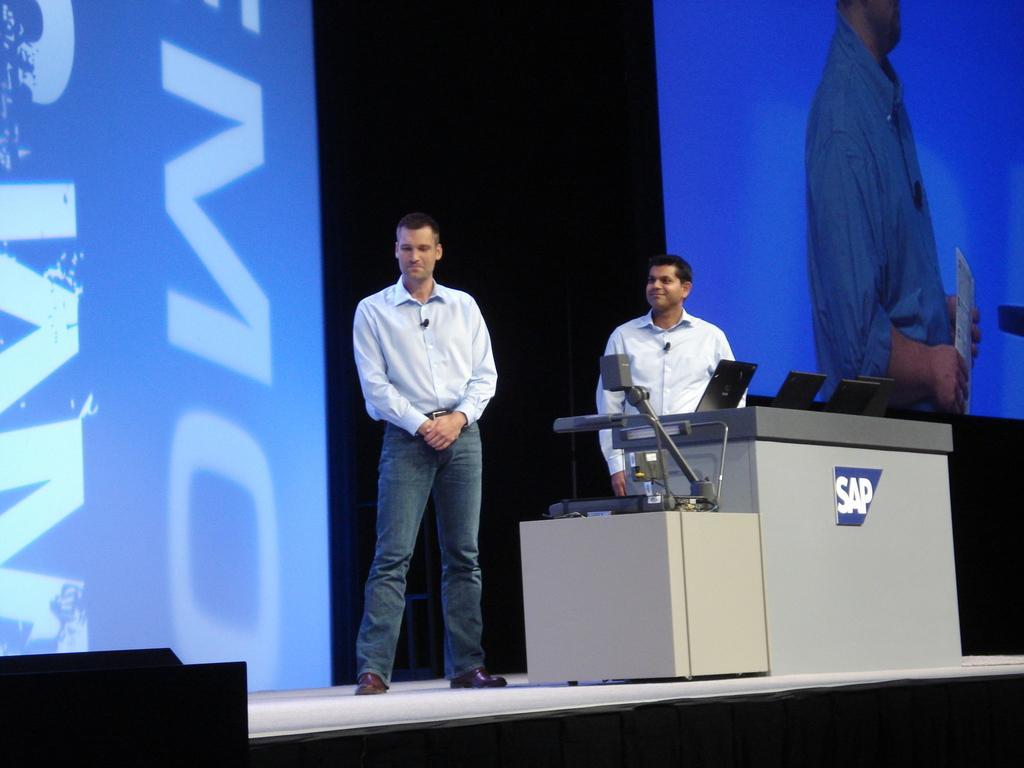How would you summarize this image in a sentence or two? In this image I can see two men standing on the stage and smiling. In front of these men there are tables on which few laptops and some other objects are placed. In the background there are two screens on which I can see the text and an image of a person. 